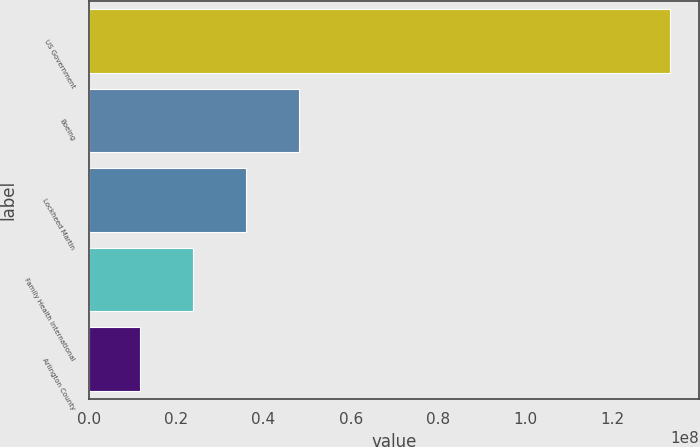Convert chart. <chart><loc_0><loc_0><loc_500><loc_500><bar_chart><fcel>US Government<fcel>Boeing<fcel>Lockheed Martin<fcel>Family Health International<fcel>Arlington County<nl><fcel>1.3305e+08<fcel>4.81246e+07<fcel>3.59924e+07<fcel>2.38602e+07<fcel>1.1728e+07<nl></chart> 